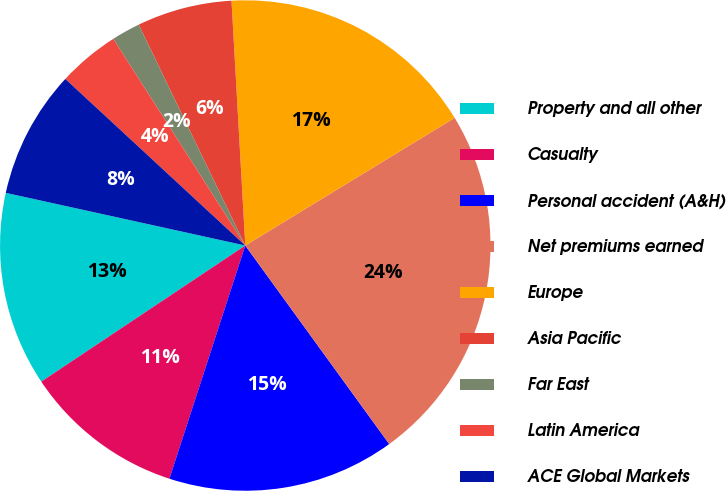Convert chart. <chart><loc_0><loc_0><loc_500><loc_500><pie_chart><fcel>Property and all other<fcel>Casualty<fcel>Personal accident (A&H)<fcel>Net premiums earned<fcel>Europe<fcel>Asia Pacific<fcel>Far East<fcel>Latin America<fcel>ACE Global Markets<nl><fcel>12.81%<fcel>10.63%<fcel>14.99%<fcel>23.73%<fcel>17.18%<fcel>6.26%<fcel>1.89%<fcel>4.07%<fcel>8.44%<nl></chart> 